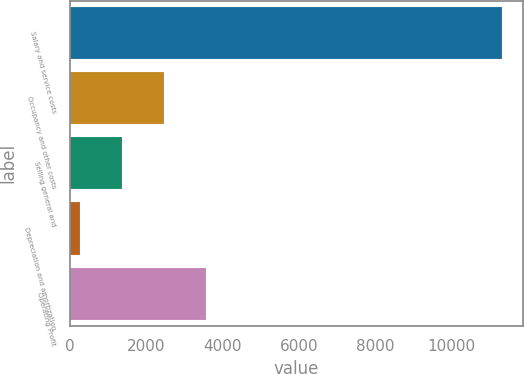<chart> <loc_0><loc_0><loc_500><loc_500><bar_chart><fcel>Salary and service costs<fcel>Occupancy and other costs<fcel>Selling general and<fcel>Depreciation and amortization<fcel>Operating Profit<nl><fcel>11306.1<fcel>2472.42<fcel>1368.21<fcel>264<fcel>3576.63<nl></chart> 